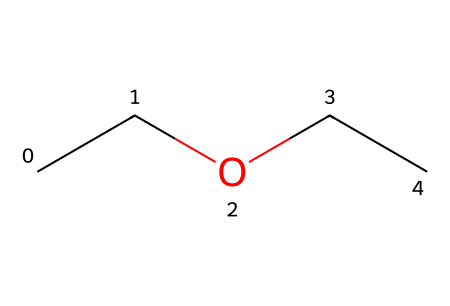How many carbon atoms are present in diethyl ether? The SMILES representation "CCOCC" indicates the presence of 4 carbon atoms, as each "C" in the SMILES corresponds to one carbon atom.
Answer: 4 What type of functional group does diethyl ether contain? An ether is characterized by the presence of an oxygen atom bonded to two alkyl groups. The "CCOCC" structure shows that the oxygen (O) is connected to two ethyl groups (CC), confirming it is an ether.
Answer: ether What is the molecular formula of diethyl ether? By counting the number of each atom in the SMILES "CCOCC", there are 4 carbon (C), 10 hydrogen (H), and 1 oxygen (O) atom, leading to the molecular formula C4H10O.
Answer: C4H10O How many oxygen atoms are in diethyl ether? The SMILES "CCOCC" contains exactly one "O", indicating that there is only one oxygen atom in diethyl ether.
Answer: 1 Is diethyl ether a polar or non-polar solvent? Ethers generally have a slight polarity due to the presence of the oxygen atom, but diethyl ether is classified as a non-polar solvent due to its carbon chain structure dominating its properties.
Answer: non-polar What is the significance of the diethyl ether structure for its use in anesthesia? The symmetric structure of diethyl ether, with its two ethyl groups and single oxygen atom, allows for effective volatility and miscibility with lipids, which are important for its anesthetic properties in medical use.
Answer: volatility and miscibility 